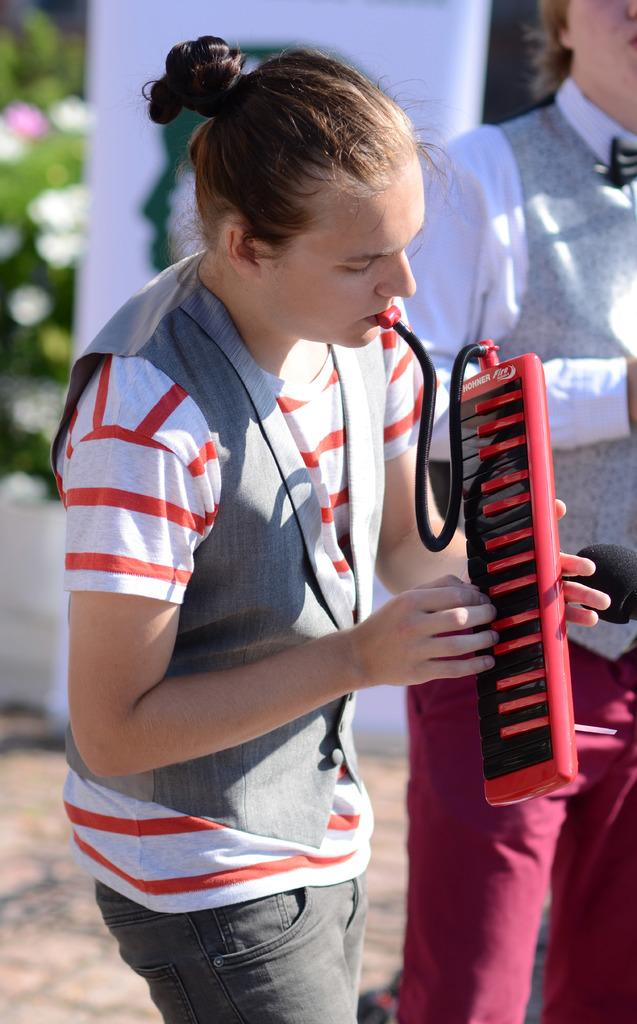How many people are in the image? There are two people standing in the image. What are the people wearing? Both people are wearing clothes. What is the person on the left side holding? The person on the left side is holding a musical instrument. Can you describe the background of the image? The background of the image is blurred. How many cats are visible in the image? There are no cats visible in the image. Is there a dog pushing the person on the right side in the image? There is no dog present in the image, and therefore no pushing is occurring. 